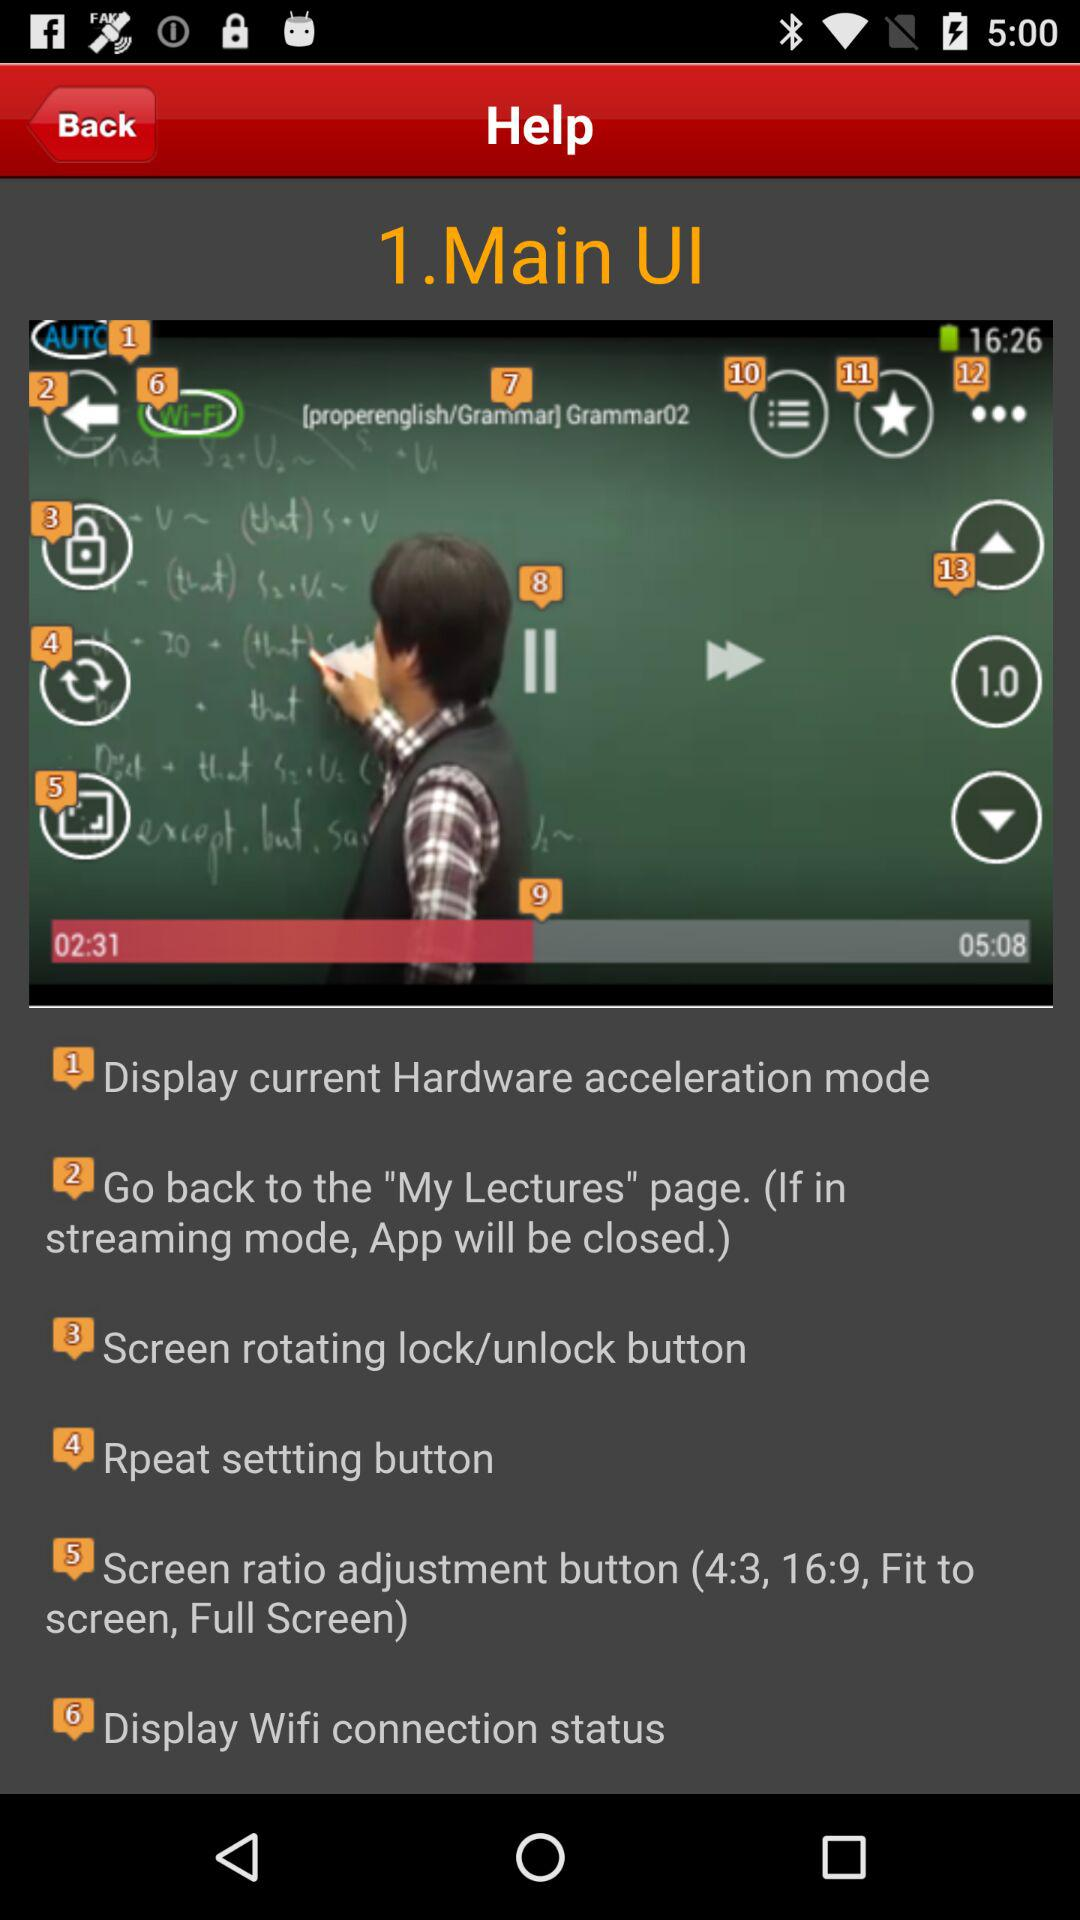Which Wi-Fi network is the device connected to?
When the provided information is insufficient, respond with <no answer>. <no answer> 